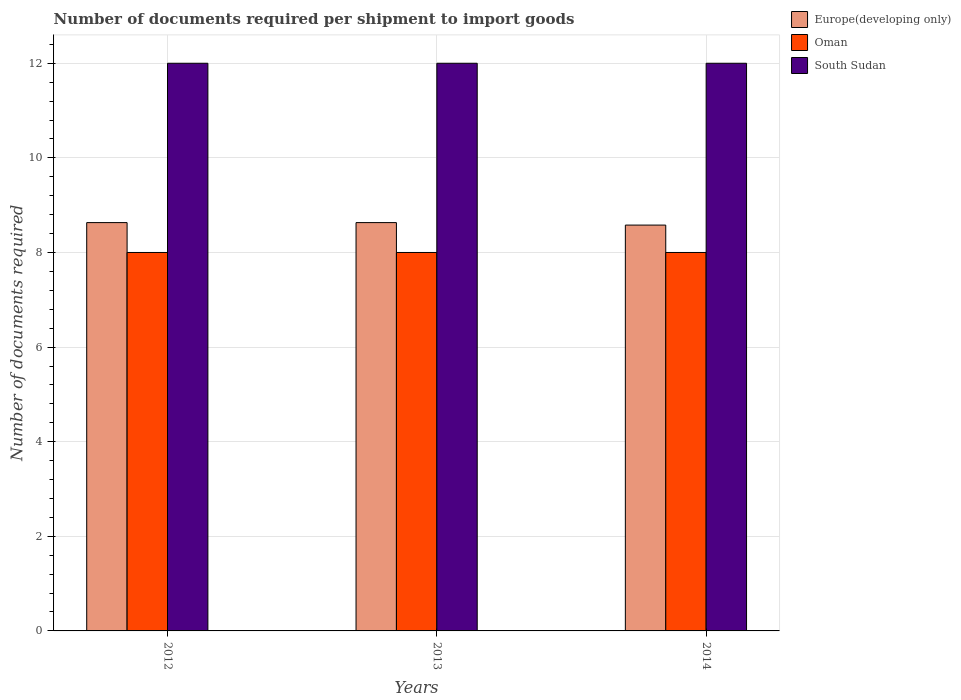Are the number of bars on each tick of the X-axis equal?
Your answer should be very brief. Yes. What is the number of documents required per shipment to import goods in Europe(developing only) in 2013?
Offer a very short reply. 8.63. Across all years, what is the maximum number of documents required per shipment to import goods in Oman?
Keep it short and to the point. 8. Across all years, what is the minimum number of documents required per shipment to import goods in Europe(developing only)?
Your answer should be very brief. 8.58. In which year was the number of documents required per shipment to import goods in Oman maximum?
Your answer should be very brief. 2012. In which year was the number of documents required per shipment to import goods in Europe(developing only) minimum?
Give a very brief answer. 2014. What is the total number of documents required per shipment to import goods in South Sudan in the graph?
Keep it short and to the point. 36. What is the difference between the number of documents required per shipment to import goods in Oman in 2012 and that in 2014?
Your answer should be very brief. 0. What is the difference between the number of documents required per shipment to import goods in Europe(developing only) in 2014 and the number of documents required per shipment to import goods in South Sudan in 2012?
Your response must be concise. -3.42. In the year 2014, what is the difference between the number of documents required per shipment to import goods in Europe(developing only) and number of documents required per shipment to import goods in South Sudan?
Offer a very short reply. -3.42. What is the ratio of the number of documents required per shipment to import goods in Europe(developing only) in 2012 to that in 2014?
Provide a succinct answer. 1.01. Is the number of documents required per shipment to import goods in Europe(developing only) in 2012 less than that in 2014?
Give a very brief answer. No. What is the difference between the highest and the second highest number of documents required per shipment to import goods in Europe(developing only)?
Your answer should be very brief. 0. What is the difference between the highest and the lowest number of documents required per shipment to import goods in South Sudan?
Make the answer very short. 0. In how many years, is the number of documents required per shipment to import goods in South Sudan greater than the average number of documents required per shipment to import goods in South Sudan taken over all years?
Your answer should be compact. 0. Is the sum of the number of documents required per shipment to import goods in Europe(developing only) in 2012 and 2013 greater than the maximum number of documents required per shipment to import goods in Oman across all years?
Make the answer very short. Yes. What does the 3rd bar from the left in 2013 represents?
Keep it short and to the point. South Sudan. What does the 1st bar from the right in 2014 represents?
Keep it short and to the point. South Sudan. Are all the bars in the graph horizontal?
Make the answer very short. No. Are the values on the major ticks of Y-axis written in scientific E-notation?
Keep it short and to the point. No. Does the graph contain grids?
Provide a short and direct response. Yes. How many legend labels are there?
Provide a succinct answer. 3. How are the legend labels stacked?
Your answer should be compact. Vertical. What is the title of the graph?
Offer a very short reply. Number of documents required per shipment to import goods. What is the label or title of the Y-axis?
Offer a terse response. Number of documents required. What is the Number of documents required in Europe(developing only) in 2012?
Keep it short and to the point. 8.63. What is the Number of documents required in South Sudan in 2012?
Give a very brief answer. 12. What is the Number of documents required in Europe(developing only) in 2013?
Provide a short and direct response. 8.63. What is the Number of documents required of Europe(developing only) in 2014?
Your response must be concise. 8.58. What is the Number of documents required in Oman in 2014?
Provide a short and direct response. 8. Across all years, what is the maximum Number of documents required in Europe(developing only)?
Provide a short and direct response. 8.63. Across all years, what is the maximum Number of documents required of South Sudan?
Your answer should be very brief. 12. Across all years, what is the minimum Number of documents required in Europe(developing only)?
Offer a terse response. 8.58. Across all years, what is the minimum Number of documents required of South Sudan?
Give a very brief answer. 12. What is the total Number of documents required of Europe(developing only) in the graph?
Ensure brevity in your answer.  25.84. What is the total Number of documents required of Oman in the graph?
Your answer should be very brief. 24. What is the total Number of documents required of South Sudan in the graph?
Offer a very short reply. 36. What is the difference between the Number of documents required in South Sudan in 2012 and that in 2013?
Offer a very short reply. 0. What is the difference between the Number of documents required in Europe(developing only) in 2012 and that in 2014?
Make the answer very short. 0.05. What is the difference between the Number of documents required of South Sudan in 2012 and that in 2014?
Your response must be concise. 0. What is the difference between the Number of documents required of Europe(developing only) in 2013 and that in 2014?
Make the answer very short. 0.05. What is the difference between the Number of documents required of Oman in 2013 and that in 2014?
Offer a very short reply. 0. What is the difference between the Number of documents required in South Sudan in 2013 and that in 2014?
Provide a succinct answer. 0. What is the difference between the Number of documents required in Europe(developing only) in 2012 and the Number of documents required in Oman in 2013?
Keep it short and to the point. 0.63. What is the difference between the Number of documents required in Europe(developing only) in 2012 and the Number of documents required in South Sudan in 2013?
Your response must be concise. -3.37. What is the difference between the Number of documents required in Europe(developing only) in 2012 and the Number of documents required in Oman in 2014?
Keep it short and to the point. 0.63. What is the difference between the Number of documents required in Europe(developing only) in 2012 and the Number of documents required in South Sudan in 2014?
Keep it short and to the point. -3.37. What is the difference between the Number of documents required of Europe(developing only) in 2013 and the Number of documents required of Oman in 2014?
Ensure brevity in your answer.  0.63. What is the difference between the Number of documents required of Europe(developing only) in 2013 and the Number of documents required of South Sudan in 2014?
Provide a succinct answer. -3.37. What is the difference between the Number of documents required of Oman in 2013 and the Number of documents required of South Sudan in 2014?
Your answer should be compact. -4. What is the average Number of documents required in Europe(developing only) per year?
Your response must be concise. 8.61. What is the average Number of documents required in Oman per year?
Your response must be concise. 8. What is the average Number of documents required of South Sudan per year?
Ensure brevity in your answer.  12. In the year 2012, what is the difference between the Number of documents required in Europe(developing only) and Number of documents required in Oman?
Keep it short and to the point. 0.63. In the year 2012, what is the difference between the Number of documents required in Europe(developing only) and Number of documents required in South Sudan?
Provide a short and direct response. -3.37. In the year 2013, what is the difference between the Number of documents required in Europe(developing only) and Number of documents required in Oman?
Provide a succinct answer. 0.63. In the year 2013, what is the difference between the Number of documents required of Europe(developing only) and Number of documents required of South Sudan?
Your answer should be very brief. -3.37. In the year 2014, what is the difference between the Number of documents required in Europe(developing only) and Number of documents required in Oman?
Offer a very short reply. 0.58. In the year 2014, what is the difference between the Number of documents required in Europe(developing only) and Number of documents required in South Sudan?
Offer a terse response. -3.42. In the year 2014, what is the difference between the Number of documents required of Oman and Number of documents required of South Sudan?
Your response must be concise. -4. What is the ratio of the Number of documents required in Europe(developing only) in 2012 to that in 2014?
Provide a short and direct response. 1.01. What is the ratio of the Number of documents required of Oman in 2012 to that in 2014?
Offer a terse response. 1. What is the ratio of the Number of documents required of South Sudan in 2012 to that in 2014?
Provide a succinct answer. 1. What is the ratio of the Number of documents required of Europe(developing only) in 2013 to that in 2014?
Keep it short and to the point. 1.01. What is the ratio of the Number of documents required of Oman in 2013 to that in 2014?
Your response must be concise. 1. What is the ratio of the Number of documents required in South Sudan in 2013 to that in 2014?
Make the answer very short. 1. What is the difference between the highest and the second highest Number of documents required in Europe(developing only)?
Provide a short and direct response. 0. What is the difference between the highest and the second highest Number of documents required in South Sudan?
Offer a terse response. 0. What is the difference between the highest and the lowest Number of documents required of Europe(developing only)?
Your answer should be very brief. 0.05. What is the difference between the highest and the lowest Number of documents required in South Sudan?
Ensure brevity in your answer.  0. 